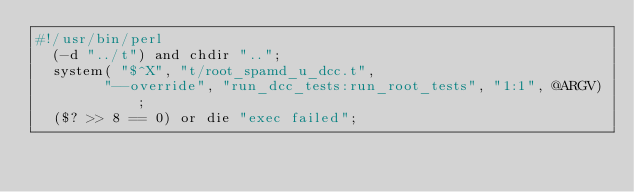<code> <loc_0><loc_0><loc_500><loc_500><_Perl_>#!/usr/bin/perl
  (-d "../t") and chdir "..";
  system( "$^X", "t/root_spamd_u_dcc.t",
        "--override", "run_dcc_tests:run_root_tests", "1:1", @ARGV);
  ($? >> 8 == 0) or die "exec failed";
  

</code> 